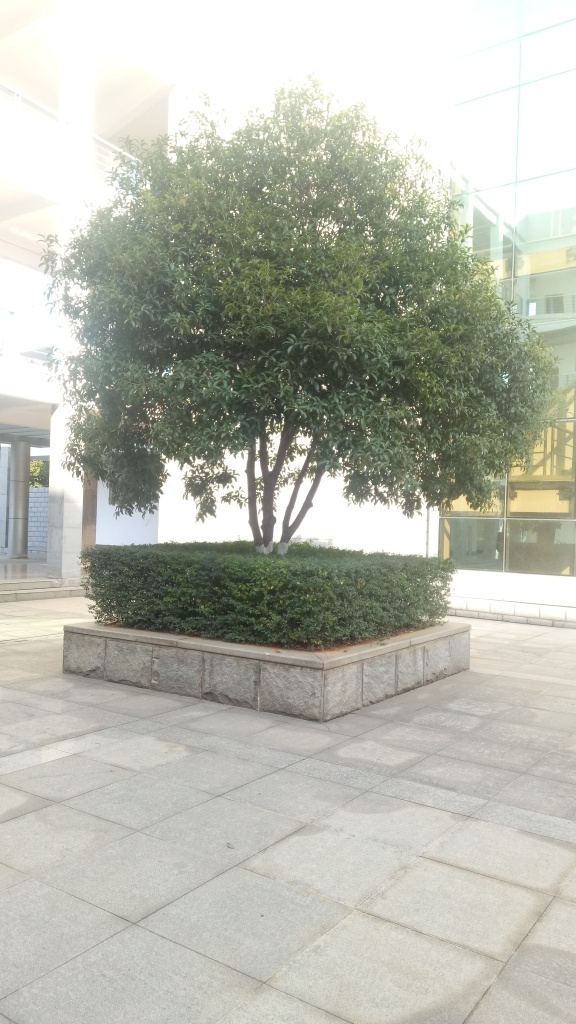What kind of atmosphere does the image convey? The image evokes a peaceful and orderly atmosphere. The well-maintained tree and trimmed hedges, along with the clean and structured environment, create an impression of tranquility and meticulousness. 